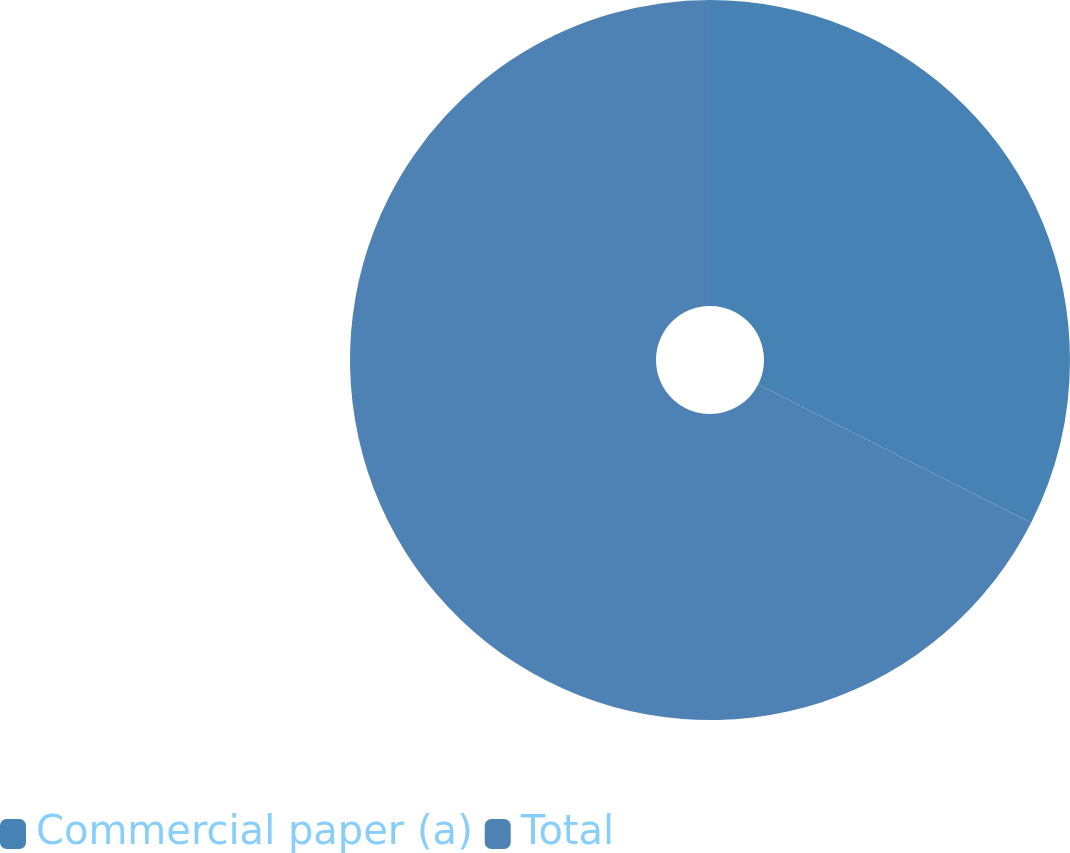Convert chart to OTSL. <chart><loc_0><loc_0><loc_500><loc_500><pie_chart><fcel>Commercial paper (a)<fcel>Total<nl><fcel>32.47%<fcel>67.53%<nl></chart> 